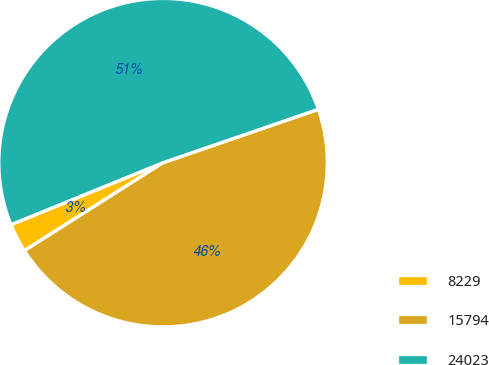Convert chart. <chart><loc_0><loc_0><loc_500><loc_500><pie_chart><fcel>8229<fcel>15794<fcel>24023<nl><fcel>2.84%<fcel>46.27%<fcel>50.89%<nl></chart> 